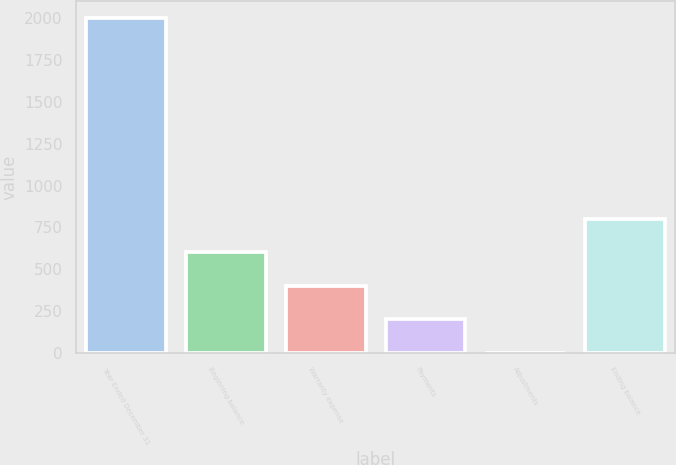<chart> <loc_0><loc_0><loc_500><loc_500><bar_chart><fcel>Year Ended December 31<fcel>Beginning balance<fcel>Warranty expense<fcel>Payments<fcel>Adjustments<fcel>Ending balance<nl><fcel>2004<fcel>602.6<fcel>402.4<fcel>202.2<fcel>2<fcel>802.8<nl></chart> 